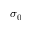<formula> <loc_0><loc_0><loc_500><loc_500>\sigma _ { 0 }</formula> 